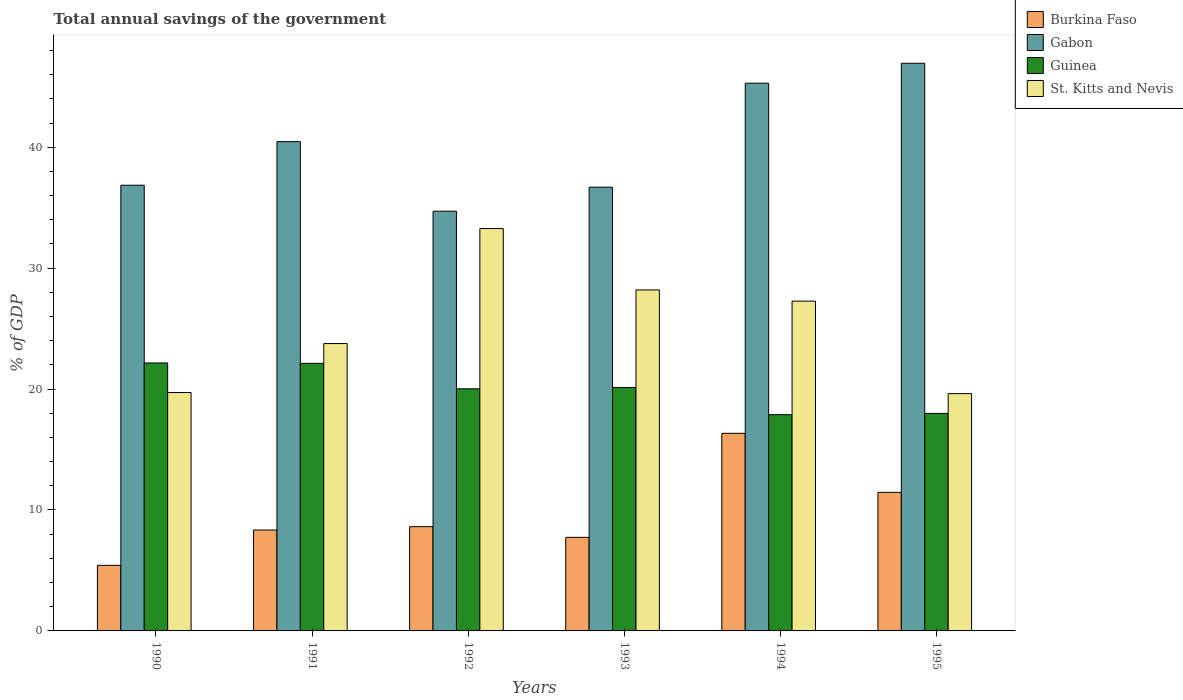Are the number of bars per tick equal to the number of legend labels?
Your answer should be very brief. Yes. Are the number of bars on each tick of the X-axis equal?
Provide a succinct answer. Yes. How many bars are there on the 3rd tick from the left?
Make the answer very short. 4. What is the label of the 1st group of bars from the left?
Make the answer very short. 1990. In how many cases, is the number of bars for a given year not equal to the number of legend labels?
Provide a short and direct response. 0. What is the total annual savings of the government in St. Kitts and Nevis in 1991?
Provide a short and direct response. 23.76. Across all years, what is the maximum total annual savings of the government in Burkina Faso?
Your answer should be very brief. 16.34. Across all years, what is the minimum total annual savings of the government in Guinea?
Give a very brief answer. 17.88. In which year was the total annual savings of the government in Gabon maximum?
Provide a succinct answer. 1995. In which year was the total annual savings of the government in Burkina Faso minimum?
Ensure brevity in your answer.  1990. What is the total total annual savings of the government in St. Kitts and Nevis in the graph?
Ensure brevity in your answer.  151.84. What is the difference between the total annual savings of the government in Burkina Faso in 1993 and that in 1995?
Ensure brevity in your answer.  -3.72. What is the difference between the total annual savings of the government in Guinea in 1994 and the total annual savings of the government in Burkina Faso in 1995?
Keep it short and to the point. 6.42. What is the average total annual savings of the government in Guinea per year?
Offer a very short reply. 20.05. In the year 1994, what is the difference between the total annual savings of the government in Burkina Faso and total annual savings of the government in Guinea?
Offer a very short reply. -1.54. What is the ratio of the total annual savings of the government in Burkina Faso in 1990 to that in 1992?
Give a very brief answer. 0.63. What is the difference between the highest and the second highest total annual savings of the government in Burkina Faso?
Give a very brief answer. 4.88. What is the difference between the highest and the lowest total annual savings of the government in Burkina Faso?
Offer a terse response. 10.92. Is the sum of the total annual savings of the government in Gabon in 1991 and 1995 greater than the maximum total annual savings of the government in St. Kitts and Nevis across all years?
Offer a very short reply. Yes. What does the 1st bar from the left in 1995 represents?
Ensure brevity in your answer.  Burkina Faso. What does the 1st bar from the right in 1992 represents?
Offer a terse response. St. Kitts and Nevis. Are all the bars in the graph horizontal?
Ensure brevity in your answer.  No. Are the values on the major ticks of Y-axis written in scientific E-notation?
Your response must be concise. No. Does the graph contain any zero values?
Give a very brief answer. No. Does the graph contain grids?
Ensure brevity in your answer.  No. Where does the legend appear in the graph?
Offer a very short reply. Top right. How are the legend labels stacked?
Give a very brief answer. Vertical. What is the title of the graph?
Your answer should be compact. Total annual savings of the government. Does "South Sudan" appear as one of the legend labels in the graph?
Offer a very short reply. No. What is the label or title of the X-axis?
Make the answer very short. Years. What is the label or title of the Y-axis?
Your answer should be compact. % of GDP. What is the % of GDP in Burkina Faso in 1990?
Your answer should be compact. 5.42. What is the % of GDP in Gabon in 1990?
Offer a very short reply. 36.86. What is the % of GDP in Guinea in 1990?
Your answer should be very brief. 22.16. What is the % of GDP of St. Kitts and Nevis in 1990?
Your response must be concise. 19.71. What is the % of GDP of Burkina Faso in 1991?
Your answer should be compact. 8.34. What is the % of GDP of Gabon in 1991?
Keep it short and to the point. 40.46. What is the % of GDP in Guinea in 1991?
Provide a succinct answer. 22.13. What is the % of GDP of St. Kitts and Nevis in 1991?
Offer a terse response. 23.76. What is the % of GDP of Burkina Faso in 1992?
Give a very brief answer. 8.62. What is the % of GDP in Gabon in 1992?
Offer a very short reply. 34.71. What is the % of GDP in Guinea in 1992?
Your answer should be compact. 20.02. What is the % of GDP in St. Kitts and Nevis in 1992?
Your response must be concise. 33.27. What is the % of GDP in Burkina Faso in 1993?
Offer a terse response. 7.74. What is the % of GDP of Gabon in 1993?
Give a very brief answer. 36.69. What is the % of GDP of Guinea in 1993?
Provide a short and direct response. 20.13. What is the % of GDP in St. Kitts and Nevis in 1993?
Make the answer very short. 28.2. What is the % of GDP of Burkina Faso in 1994?
Ensure brevity in your answer.  16.34. What is the % of GDP of Gabon in 1994?
Give a very brief answer. 45.29. What is the % of GDP of Guinea in 1994?
Your response must be concise. 17.88. What is the % of GDP in St. Kitts and Nevis in 1994?
Offer a very short reply. 27.27. What is the % of GDP of Burkina Faso in 1995?
Your answer should be very brief. 11.46. What is the % of GDP in Gabon in 1995?
Your response must be concise. 46.94. What is the % of GDP in Guinea in 1995?
Your response must be concise. 17.99. What is the % of GDP in St. Kitts and Nevis in 1995?
Ensure brevity in your answer.  19.62. Across all years, what is the maximum % of GDP of Burkina Faso?
Provide a short and direct response. 16.34. Across all years, what is the maximum % of GDP of Gabon?
Make the answer very short. 46.94. Across all years, what is the maximum % of GDP of Guinea?
Give a very brief answer. 22.16. Across all years, what is the maximum % of GDP in St. Kitts and Nevis?
Ensure brevity in your answer.  33.27. Across all years, what is the minimum % of GDP of Burkina Faso?
Ensure brevity in your answer.  5.42. Across all years, what is the minimum % of GDP in Gabon?
Make the answer very short. 34.71. Across all years, what is the minimum % of GDP in Guinea?
Give a very brief answer. 17.88. Across all years, what is the minimum % of GDP in St. Kitts and Nevis?
Your response must be concise. 19.62. What is the total % of GDP of Burkina Faso in the graph?
Your answer should be compact. 57.93. What is the total % of GDP of Gabon in the graph?
Ensure brevity in your answer.  240.95. What is the total % of GDP of Guinea in the graph?
Make the answer very short. 120.31. What is the total % of GDP of St. Kitts and Nevis in the graph?
Provide a succinct answer. 151.84. What is the difference between the % of GDP in Burkina Faso in 1990 and that in 1991?
Your answer should be very brief. -2.92. What is the difference between the % of GDP of Gabon in 1990 and that in 1991?
Your answer should be compact. -3.6. What is the difference between the % of GDP in Guinea in 1990 and that in 1991?
Your response must be concise. 0.03. What is the difference between the % of GDP in St. Kitts and Nevis in 1990 and that in 1991?
Provide a succinct answer. -4.05. What is the difference between the % of GDP of Burkina Faso in 1990 and that in 1992?
Your answer should be compact. -3.2. What is the difference between the % of GDP of Gabon in 1990 and that in 1992?
Offer a very short reply. 2.15. What is the difference between the % of GDP in Guinea in 1990 and that in 1992?
Offer a terse response. 2.14. What is the difference between the % of GDP of St. Kitts and Nevis in 1990 and that in 1992?
Offer a terse response. -13.56. What is the difference between the % of GDP of Burkina Faso in 1990 and that in 1993?
Your answer should be compact. -2.31. What is the difference between the % of GDP of Gabon in 1990 and that in 1993?
Provide a short and direct response. 0.16. What is the difference between the % of GDP in Guinea in 1990 and that in 1993?
Ensure brevity in your answer.  2.03. What is the difference between the % of GDP in St. Kitts and Nevis in 1990 and that in 1993?
Provide a succinct answer. -8.48. What is the difference between the % of GDP of Burkina Faso in 1990 and that in 1994?
Give a very brief answer. -10.92. What is the difference between the % of GDP in Gabon in 1990 and that in 1994?
Provide a succinct answer. -8.44. What is the difference between the % of GDP in Guinea in 1990 and that in 1994?
Make the answer very short. 4.28. What is the difference between the % of GDP of St. Kitts and Nevis in 1990 and that in 1994?
Keep it short and to the point. -7.56. What is the difference between the % of GDP in Burkina Faso in 1990 and that in 1995?
Your response must be concise. -6.03. What is the difference between the % of GDP of Gabon in 1990 and that in 1995?
Offer a very short reply. -10.09. What is the difference between the % of GDP of Guinea in 1990 and that in 1995?
Your answer should be compact. 4.17. What is the difference between the % of GDP in St. Kitts and Nevis in 1990 and that in 1995?
Provide a succinct answer. 0.09. What is the difference between the % of GDP of Burkina Faso in 1991 and that in 1992?
Offer a very short reply. -0.28. What is the difference between the % of GDP in Gabon in 1991 and that in 1992?
Your answer should be compact. 5.75. What is the difference between the % of GDP of Guinea in 1991 and that in 1992?
Your answer should be compact. 2.11. What is the difference between the % of GDP in St. Kitts and Nevis in 1991 and that in 1992?
Make the answer very short. -9.51. What is the difference between the % of GDP of Burkina Faso in 1991 and that in 1993?
Provide a succinct answer. 0.61. What is the difference between the % of GDP of Gabon in 1991 and that in 1993?
Your answer should be very brief. 3.77. What is the difference between the % of GDP of Guinea in 1991 and that in 1993?
Ensure brevity in your answer.  2. What is the difference between the % of GDP in St. Kitts and Nevis in 1991 and that in 1993?
Offer a terse response. -4.43. What is the difference between the % of GDP in Burkina Faso in 1991 and that in 1994?
Your response must be concise. -8. What is the difference between the % of GDP in Gabon in 1991 and that in 1994?
Give a very brief answer. -4.83. What is the difference between the % of GDP in Guinea in 1991 and that in 1994?
Your answer should be compact. 4.25. What is the difference between the % of GDP in St. Kitts and Nevis in 1991 and that in 1994?
Your answer should be very brief. -3.51. What is the difference between the % of GDP of Burkina Faso in 1991 and that in 1995?
Provide a short and direct response. -3.11. What is the difference between the % of GDP of Gabon in 1991 and that in 1995?
Offer a terse response. -6.48. What is the difference between the % of GDP in Guinea in 1991 and that in 1995?
Your answer should be very brief. 4.14. What is the difference between the % of GDP of St. Kitts and Nevis in 1991 and that in 1995?
Provide a short and direct response. 4.14. What is the difference between the % of GDP in Burkina Faso in 1992 and that in 1993?
Offer a very short reply. 0.88. What is the difference between the % of GDP in Gabon in 1992 and that in 1993?
Keep it short and to the point. -1.99. What is the difference between the % of GDP of Guinea in 1992 and that in 1993?
Your answer should be compact. -0.11. What is the difference between the % of GDP in St. Kitts and Nevis in 1992 and that in 1993?
Your response must be concise. 5.08. What is the difference between the % of GDP of Burkina Faso in 1992 and that in 1994?
Give a very brief answer. -7.72. What is the difference between the % of GDP of Gabon in 1992 and that in 1994?
Your answer should be very brief. -10.58. What is the difference between the % of GDP of Guinea in 1992 and that in 1994?
Your response must be concise. 2.14. What is the difference between the % of GDP in St. Kitts and Nevis in 1992 and that in 1994?
Provide a succinct answer. 6. What is the difference between the % of GDP of Burkina Faso in 1992 and that in 1995?
Keep it short and to the point. -2.84. What is the difference between the % of GDP of Gabon in 1992 and that in 1995?
Provide a succinct answer. -12.24. What is the difference between the % of GDP of Guinea in 1992 and that in 1995?
Give a very brief answer. 2.03. What is the difference between the % of GDP in St. Kitts and Nevis in 1992 and that in 1995?
Your response must be concise. 13.65. What is the difference between the % of GDP in Burkina Faso in 1993 and that in 1994?
Your response must be concise. -8.6. What is the difference between the % of GDP of Gabon in 1993 and that in 1994?
Give a very brief answer. -8.6. What is the difference between the % of GDP in Guinea in 1993 and that in 1994?
Offer a terse response. 2.25. What is the difference between the % of GDP in St. Kitts and Nevis in 1993 and that in 1994?
Ensure brevity in your answer.  0.93. What is the difference between the % of GDP in Burkina Faso in 1993 and that in 1995?
Keep it short and to the point. -3.72. What is the difference between the % of GDP in Gabon in 1993 and that in 1995?
Make the answer very short. -10.25. What is the difference between the % of GDP in Guinea in 1993 and that in 1995?
Offer a terse response. 2.14. What is the difference between the % of GDP in St. Kitts and Nevis in 1993 and that in 1995?
Provide a succinct answer. 8.57. What is the difference between the % of GDP in Burkina Faso in 1994 and that in 1995?
Ensure brevity in your answer.  4.88. What is the difference between the % of GDP of Gabon in 1994 and that in 1995?
Give a very brief answer. -1.65. What is the difference between the % of GDP of Guinea in 1994 and that in 1995?
Give a very brief answer. -0.1. What is the difference between the % of GDP in St. Kitts and Nevis in 1994 and that in 1995?
Make the answer very short. 7.65. What is the difference between the % of GDP of Burkina Faso in 1990 and the % of GDP of Gabon in 1991?
Make the answer very short. -35.04. What is the difference between the % of GDP in Burkina Faso in 1990 and the % of GDP in Guinea in 1991?
Your answer should be very brief. -16.71. What is the difference between the % of GDP in Burkina Faso in 1990 and the % of GDP in St. Kitts and Nevis in 1991?
Offer a very short reply. -18.34. What is the difference between the % of GDP in Gabon in 1990 and the % of GDP in Guinea in 1991?
Ensure brevity in your answer.  14.73. What is the difference between the % of GDP of Gabon in 1990 and the % of GDP of St. Kitts and Nevis in 1991?
Make the answer very short. 13.09. What is the difference between the % of GDP of Guinea in 1990 and the % of GDP of St. Kitts and Nevis in 1991?
Ensure brevity in your answer.  -1.6. What is the difference between the % of GDP of Burkina Faso in 1990 and the % of GDP of Gabon in 1992?
Provide a short and direct response. -29.28. What is the difference between the % of GDP of Burkina Faso in 1990 and the % of GDP of Guinea in 1992?
Provide a short and direct response. -14.6. What is the difference between the % of GDP of Burkina Faso in 1990 and the % of GDP of St. Kitts and Nevis in 1992?
Provide a succinct answer. -27.85. What is the difference between the % of GDP of Gabon in 1990 and the % of GDP of Guinea in 1992?
Provide a succinct answer. 16.84. What is the difference between the % of GDP in Gabon in 1990 and the % of GDP in St. Kitts and Nevis in 1992?
Your answer should be very brief. 3.58. What is the difference between the % of GDP in Guinea in 1990 and the % of GDP in St. Kitts and Nevis in 1992?
Offer a terse response. -11.11. What is the difference between the % of GDP of Burkina Faso in 1990 and the % of GDP of Gabon in 1993?
Provide a succinct answer. -31.27. What is the difference between the % of GDP in Burkina Faso in 1990 and the % of GDP in Guinea in 1993?
Offer a terse response. -14.71. What is the difference between the % of GDP in Burkina Faso in 1990 and the % of GDP in St. Kitts and Nevis in 1993?
Keep it short and to the point. -22.77. What is the difference between the % of GDP in Gabon in 1990 and the % of GDP in Guinea in 1993?
Offer a very short reply. 16.73. What is the difference between the % of GDP of Gabon in 1990 and the % of GDP of St. Kitts and Nevis in 1993?
Provide a succinct answer. 8.66. What is the difference between the % of GDP in Guinea in 1990 and the % of GDP in St. Kitts and Nevis in 1993?
Your answer should be very brief. -6.04. What is the difference between the % of GDP of Burkina Faso in 1990 and the % of GDP of Gabon in 1994?
Your answer should be very brief. -39.87. What is the difference between the % of GDP in Burkina Faso in 1990 and the % of GDP in Guinea in 1994?
Keep it short and to the point. -12.46. What is the difference between the % of GDP of Burkina Faso in 1990 and the % of GDP of St. Kitts and Nevis in 1994?
Offer a very short reply. -21.85. What is the difference between the % of GDP in Gabon in 1990 and the % of GDP in Guinea in 1994?
Ensure brevity in your answer.  18.97. What is the difference between the % of GDP of Gabon in 1990 and the % of GDP of St. Kitts and Nevis in 1994?
Give a very brief answer. 9.58. What is the difference between the % of GDP of Guinea in 1990 and the % of GDP of St. Kitts and Nevis in 1994?
Keep it short and to the point. -5.11. What is the difference between the % of GDP of Burkina Faso in 1990 and the % of GDP of Gabon in 1995?
Make the answer very short. -41.52. What is the difference between the % of GDP in Burkina Faso in 1990 and the % of GDP in Guinea in 1995?
Offer a terse response. -12.56. What is the difference between the % of GDP of Burkina Faso in 1990 and the % of GDP of St. Kitts and Nevis in 1995?
Offer a very short reply. -14.2. What is the difference between the % of GDP of Gabon in 1990 and the % of GDP of Guinea in 1995?
Ensure brevity in your answer.  18.87. What is the difference between the % of GDP in Gabon in 1990 and the % of GDP in St. Kitts and Nevis in 1995?
Ensure brevity in your answer.  17.23. What is the difference between the % of GDP in Guinea in 1990 and the % of GDP in St. Kitts and Nevis in 1995?
Offer a very short reply. 2.54. What is the difference between the % of GDP in Burkina Faso in 1991 and the % of GDP in Gabon in 1992?
Your response must be concise. -26.36. What is the difference between the % of GDP of Burkina Faso in 1991 and the % of GDP of Guinea in 1992?
Keep it short and to the point. -11.68. What is the difference between the % of GDP in Burkina Faso in 1991 and the % of GDP in St. Kitts and Nevis in 1992?
Offer a terse response. -24.93. What is the difference between the % of GDP of Gabon in 1991 and the % of GDP of Guinea in 1992?
Offer a very short reply. 20.44. What is the difference between the % of GDP of Gabon in 1991 and the % of GDP of St. Kitts and Nevis in 1992?
Provide a short and direct response. 7.19. What is the difference between the % of GDP of Guinea in 1991 and the % of GDP of St. Kitts and Nevis in 1992?
Offer a terse response. -11.14. What is the difference between the % of GDP in Burkina Faso in 1991 and the % of GDP in Gabon in 1993?
Give a very brief answer. -28.35. What is the difference between the % of GDP of Burkina Faso in 1991 and the % of GDP of Guinea in 1993?
Your answer should be very brief. -11.79. What is the difference between the % of GDP in Burkina Faso in 1991 and the % of GDP in St. Kitts and Nevis in 1993?
Ensure brevity in your answer.  -19.85. What is the difference between the % of GDP of Gabon in 1991 and the % of GDP of Guinea in 1993?
Provide a short and direct response. 20.33. What is the difference between the % of GDP in Gabon in 1991 and the % of GDP in St. Kitts and Nevis in 1993?
Keep it short and to the point. 12.26. What is the difference between the % of GDP in Guinea in 1991 and the % of GDP in St. Kitts and Nevis in 1993?
Provide a short and direct response. -6.07. What is the difference between the % of GDP of Burkina Faso in 1991 and the % of GDP of Gabon in 1994?
Your answer should be very brief. -36.95. What is the difference between the % of GDP in Burkina Faso in 1991 and the % of GDP in Guinea in 1994?
Ensure brevity in your answer.  -9.54. What is the difference between the % of GDP in Burkina Faso in 1991 and the % of GDP in St. Kitts and Nevis in 1994?
Your answer should be compact. -18.93. What is the difference between the % of GDP in Gabon in 1991 and the % of GDP in Guinea in 1994?
Your answer should be very brief. 22.58. What is the difference between the % of GDP of Gabon in 1991 and the % of GDP of St. Kitts and Nevis in 1994?
Keep it short and to the point. 13.19. What is the difference between the % of GDP of Guinea in 1991 and the % of GDP of St. Kitts and Nevis in 1994?
Your answer should be compact. -5.14. What is the difference between the % of GDP in Burkina Faso in 1991 and the % of GDP in Gabon in 1995?
Provide a succinct answer. -38.6. What is the difference between the % of GDP in Burkina Faso in 1991 and the % of GDP in Guinea in 1995?
Give a very brief answer. -9.64. What is the difference between the % of GDP of Burkina Faso in 1991 and the % of GDP of St. Kitts and Nevis in 1995?
Offer a very short reply. -11.28. What is the difference between the % of GDP of Gabon in 1991 and the % of GDP of Guinea in 1995?
Make the answer very short. 22.47. What is the difference between the % of GDP of Gabon in 1991 and the % of GDP of St. Kitts and Nevis in 1995?
Provide a succinct answer. 20.84. What is the difference between the % of GDP in Guinea in 1991 and the % of GDP in St. Kitts and Nevis in 1995?
Ensure brevity in your answer.  2.51. What is the difference between the % of GDP in Burkina Faso in 1992 and the % of GDP in Gabon in 1993?
Your answer should be compact. -28.07. What is the difference between the % of GDP of Burkina Faso in 1992 and the % of GDP of Guinea in 1993?
Give a very brief answer. -11.51. What is the difference between the % of GDP in Burkina Faso in 1992 and the % of GDP in St. Kitts and Nevis in 1993?
Your answer should be compact. -19.58. What is the difference between the % of GDP in Gabon in 1992 and the % of GDP in Guinea in 1993?
Keep it short and to the point. 14.58. What is the difference between the % of GDP in Gabon in 1992 and the % of GDP in St. Kitts and Nevis in 1993?
Ensure brevity in your answer.  6.51. What is the difference between the % of GDP in Guinea in 1992 and the % of GDP in St. Kitts and Nevis in 1993?
Your answer should be compact. -8.18. What is the difference between the % of GDP in Burkina Faso in 1992 and the % of GDP in Gabon in 1994?
Provide a succinct answer. -36.67. What is the difference between the % of GDP of Burkina Faso in 1992 and the % of GDP of Guinea in 1994?
Provide a short and direct response. -9.26. What is the difference between the % of GDP of Burkina Faso in 1992 and the % of GDP of St. Kitts and Nevis in 1994?
Give a very brief answer. -18.65. What is the difference between the % of GDP in Gabon in 1992 and the % of GDP in Guinea in 1994?
Make the answer very short. 16.82. What is the difference between the % of GDP in Gabon in 1992 and the % of GDP in St. Kitts and Nevis in 1994?
Offer a very short reply. 7.43. What is the difference between the % of GDP in Guinea in 1992 and the % of GDP in St. Kitts and Nevis in 1994?
Provide a short and direct response. -7.25. What is the difference between the % of GDP of Burkina Faso in 1992 and the % of GDP of Gabon in 1995?
Ensure brevity in your answer.  -38.32. What is the difference between the % of GDP in Burkina Faso in 1992 and the % of GDP in Guinea in 1995?
Your response must be concise. -9.37. What is the difference between the % of GDP of Burkina Faso in 1992 and the % of GDP of St. Kitts and Nevis in 1995?
Provide a succinct answer. -11. What is the difference between the % of GDP in Gabon in 1992 and the % of GDP in Guinea in 1995?
Keep it short and to the point. 16.72. What is the difference between the % of GDP in Gabon in 1992 and the % of GDP in St. Kitts and Nevis in 1995?
Keep it short and to the point. 15.08. What is the difference between the % of GDP of Guinea in 1992 and the % of GDP of St. Kitts and Nevis in 1995?
Ensure brevity in your answer.  0.4. What is the difference between the % of GDP in Burkina Faso in 1993 and the % of GDP in Gabon in 1994?
Give a very brief answer. -37.55. What is the difference between the % of GDP in Burkina Faso in 1993 and the % of GDP in Guinea in 1994?
Offer a very short reply. -10.15. What is the difference between the % of GDP in Burkina Faso in 1993 and the % of GDP in St. Kitts and Nevis in 1994?
Keep it short and to the point. -19.54. What is the difference between the % of GDP in Gabon in 1993 and the % of GDP in Guinea in 1994?
Make the answer very short. 18.81. What is the difference between the % of GDP of Gabon in 1993 and the % of GDP of St. Kitts and Nevis in 1994?
Give a very brief answer. 9.42. What is the difference between the % of GDP in Guinea in 1993 and the % of GDP in St. Kitts and Nevis in 1994?
Your answer should be compact. -7.14. What is the difference between the % of GDP in Burkina Faso in 1993 and the % of GDP in Gabon in 1995?
Your response must be concise. -39.21. What is the difference between the % of GDP of Burkina Faso in 1993 and the % of GDP of Guinea in 1995?
Make the answer very short. -10.25. What is the difference between the % of GDP of Burkina Faso in 1993 and the % of GDP of St. Kitts and Nevis in 1995?
Keep it short and to the point. -11.89. What is the difference between the % of GDP in Gabon in 1993 and the % of GDP in Guinea in 1995?
Offer a terse response. 18.71. What is the difference between the % of GDP in Gabon in 1993 and the % of GDP in St. Kitts and Nevis in 1995?
Your answer should be compact. 17.07. What is the difference between the % of GDP in Guinea in 1993 and the % of GDP in St. Kitts and Nevis in 1995?
Keep it short and to the point. 0.51. What is the difference between the % of GDP in Burkina Faso in 1994 and the % of GDP in Gabon in 1995?
Your answer should be very brief. -30.6. What is the difference between the % of GDP in Burkina Faso in 1994 and the % of GDP in Guinea in 1995?
Your answer should be very brief. -1.65. What is the difference between the % of GDP of Burkina Faso in 1994 and the % of GDP of St. Kitts and Nevis in 1995?
Provide a succinct answer. -3.28. What is the difference between the % of GDP in Gabon in 1994 and the % of GDP in Guinea in 1995?
Give a very brief answer. 27.31. What is the difference between the % of GDP of Gabon in 1994 and the % of GDP of St. Kitts and Nevis in 1995?
Offer a terse response. 25.67. What is the difference between the % of GDP in Guinea in 1994 and the % of GDP in St. Kitts and Nevis in 1995?
Your answer should be very brief. -1.74. What is the average % of GDP of Burkina Faso per year?
Your answer should be very brief. 9.65. What is the average % of GDP in Gabon per year?
Keep it short and to the point. 40.16. What is the average % of GDP of Guinea per year?
Your answer should be compact. 20.05. What is the average % of GDP in St. Kitts and Nevis per year?
Give a very brief answer. 25.31. In the year 1990, what is the difference between the % of GDP of Burkina Faso and % of GDP of Gabon?
Your answer should be very brief. -31.43. In the year 1990, what is the difference between the % of GDP in Burkina Faso and % of GDP in Guinea?
Your response must be concise. -16.74. In the year 1990, what is the difference between the % of GDP in Burkina Faso and % of GDP in St. Kitts and Nevis?
Your response must be concise. -14.29. In the year 1990, what is the difference between the % of GDP of Gabon and % of GDP of Guinea?
Keep it short and to the point. 14.7. In the year 1990, what is the difference between the % of GDP of Gabon and % of GDP of St. Kitts and Nevis?
Ensure brevity in your answer.  17.14. In the year 1990, what is the difference between the % of GDP in Guinea and % of GDP in St. Kitts and Nevis?
Provide a short and direct response. 2.44. In the year 1991, what is the difference between the % of GDP in Burkina Faso and % of GDP in Gabon?
Your answer should be compact. -32.12. In the year 1991, what is the difference between the % of GDP of Burkina Faso and % of GDP of Guinea?
Your answer should be compact. -13.79. In the year 1991, what is the difference between the % of GDP of Burkina Faso and % of GDP of St. Kitts and Nevis?
Give a very brief answer. -15.42. In the year 1991, what is the difference between the % of GDP in Gabon and % of GDP in Guinea?
Provide a succinct answer. 18.33. In the year 1991, what is the difference between the % of GDP in Gabon and % of GDP in St. Kitts and Nevis?
Your answer should be very brief. 16.7. In the year 1991, what is the difference between the % of GDP of Guinea and % of GDP of St. Kitts and Nevis?
Your response must be concise. -1.63. In the year 1992, what is the difference between the % of GDP in Burkina Faso and % of GDP in Gabon?
Ensure brevity in your answer.  -26.09. In the year 1992, what is the difference between the % of GDP in Burkina Faso and % of GDP in Guinea?
Keep it short and to the point. -11.4. In the year 1992, what is the difference between the % of GDP in Burkina Faso and % of GDP in St. Kitts and Nevis?
Your answer should be compact. -24.65. In the year 1992, what is the difference between the % of GDP in Gabon and % of GDP in Guinea?
Your answer should be very brief. 14.69. In the year 1992, what is the difference between the % of GDP of Gabon and % of GDP of St. Kitts and Nevis?
Ensure brevity in your answer.  1.43. In the year 1992, what is the difference between the % of GDP of Guinea and % of GDP of St. Kitts and Nevis?
Your response must be concise. -13.25. In the year 1993, what is the difference between the % of GDP of Burkina Faso and % of GDP of Gabon?
Offer a terse response. -28.96. In the year 1993, what is the difference between the % of GDP in Burkina Faso and % of GDP in Guinea?
Keep it short and to the point. -12.39. In the year 1993, what is the difference between the % of GDP of Burkina Faso and % of GDP of St. Kitts and Nevis?
Offer a very short reply. -20.46. In the year 1993, what is the difference between the % of GDP in Gabon and % of GDP in Guinea?
Your answer should be compact. 16.56. In the year 1993, what is the difference between the % of GDP in Gabon and % of GDP in St. Kitts and Nevis?
Offer a very short reply. 8.5. In the year 1993, what is the difference between the % of GDP in Guinea and % of GDP in St. Kitts and Nevis?
Your response must be concise. -8.07. In the year 1994, what is the difference between the % of GDP in Burkina Faso and % of GDP in Gabon?
Make the answer very short. -28.95. In the year 1994, what is the difference between the % of GDP of Burkina Faso and % of GDP of Guinea?
Provide a short and direct response. -1.54. In the year 1994, what is the difference between the % of GDP of Burkina Faso and % of GDP of St. Kitts and Nevis?
Provide a succinct answer. -10.93. In the year 1994, what is the difference between the % of GDP in Gabon and % of GDP in Guinea?
Give a very brief answer. 27.41. In the year 1994, what is the difference between the % of GDP of Gabon and % of GDP of St. Kitts and Nevis?
Provide a succinct answer. 18.02. In the year 1994, what is the difference between the % of GDP in Guinea and % of GDP in St. Kitts and Nevis?
Offer a terse response. -9.39. In the year 1995, what is the difference between the % of GDP in Burkina Faso and % of GDP in Gabon?
Ensure brevity in your answer.  -35.48. In the year 1995, what is the difference between the % of GDP of Burkina Faso and % of GDP of Guinea?
Your answer should be compact. -6.53. In the year 1995, what is the difference between the % of GDP in Burkina Faso and % of GDP in St. Kitts and Nevis?
Give a very brief answer. -8.16. In the year 1995, what is the difference between the % of GDP in Gabon and % of GDP in Guinea?
Provide a short and direct response. 28.96. In the year 1995, what is the difference between the % of GDP in Gabon and % of GDP in St. Kitts and Nevis?
Ensure brevity in your answer.  27.32. In the year 1995, what is the difference between the % of GDP of Guinea and % of GDP of St. Kitts and Nevis?
Ensure brevity in your answer.  -1.64. What is the ratio of the % of GDP of Burkina Faso in 1990 to that in 1991?
Your response must be concise. 0.65. What is the ratio of the % of GDP in Gabon in 1990 to that in 1991?
Offer a terse response. 0.91. What is the ratio of the % of GDP in St. Kitts and Nevis in 1990 to that in 1991?
Your answer should be very brief. 0.83. What is the ratio of the % of GDP of Burkina Faso in 1990 to that in 1992?
Give a very brief answer. 0.63. What is the ratio of the % of GDP in Gabon in 1990 to that in 1992?
Your answer should be compact. 1.06. What is the ratio of the % of GDP in Guinea in 1990 to that in 1992?
Your answer should be compact. 1.11. What is the ratio of the % of GDP in St. Kitts and Nevis in 1990 to that in 1992?
Ensure brevity in your answer.  0.59. What is the ratio of the % of GDP in Burkina Faso in 1990 to that in 1993?
Offer a terse response. 0.7. What is the ratio of the % of GDP in Gabon in 1990 to that in 1993?
Offer a terse response. 1. What is the ratio of the % of GDP in Guinea in 1990 to that in 1993?
Make the answer very short. 1.1. What is the ratio of the % of GDP of St. Kitts and Nevis in 1990 to that in 1993?
Offer a very short reply. 0.7. What is the ratio of the % of GDP in Burkina Faso in 1990 to that in 1994?
Provide a short and direct response. 0.33. What is the ratio of the % of GDP in Gabon in 1990 to that in 1994?
Your answer should be compact. 0.81. What is the ratio of the % of GDP in Guinea in 1990 to that in 1994?
Offer a terse response. 1.24. What is the ratio of the % of GDP of St. Kitts and Nevis in 1990 to that in 1994?
Your response must be concise. 0.72. What is the ratio of the % of GDP of Burkina Faso in 1990 to that in 1995?
Keep it short and to the point. 0.47. What is the ratio of the % of GDP in Gabon in 1990 to that in 1995?
Keep it short and to the point. 0.79. What is the ratio of the % of GDP in Guinea in 1990 to that in 1995?
Your answer should be very brief. 1.23. What is the ratio of the % of GDP of Burkina Faso in 1991 to that in 1992?
Give a very brief answer. 0.97. What is the ratio of the % of GDP in Gabon in 1991 to that in 1992?
Provide a succinct answer. 1.17. What is the ratio of the % of GDP in Guinea in 1991 to that in 1992?
Your answer should be very brief. 1.11. What is the ratio of the % of GDP in St. Kitts and Nevis in 1991 to that in 1992?
Your response must be concise. 0.71. What is the ratio of the % of GDP of Burkina Faso in 1991 to that in 1993?
Offer a terse response. 1.08. What is the ratio of the % of GDP of Gabon in 1991 to that in 1993?
Offer a very short reply. 1.1. What is the ratio of the % of GDP in Guinea in 1991 to that in 1993?
Provide a succinct answer. 1.1. What is the ratio of the % of GDP in St. Kitts and Nevis in 1991 to that in 1993?
Your answer should be very brief. 0.84. What is the ratio of the % of GDP in Burkina Faso in 1991 to that in 1994?
Make the answer very short. 0.51. What is the ratio of the % of GDP of Gabon in 1991 to that in 1994?
Give a very brief answer. 0.89. What is the ratio of the % of GDP of Guinea in 1991 to that in 1994?
Offer a terse response. 1.24. What is the ratio of the % of GDP in St. Kitts and Nevis in 1991 to that in 1994?
Make the answer very short. 0.87. What is the ratio of the % of GDP of Burkina Faso in 1991 to that in 1995?
Your response must be concise. 0.73. What is the ratio of the % of GDP in Gabon in 1991 to that in 1995?
Provide a short and direct response. 0.86. What is the ratio of the % of GDP in Guinea in 1991 to that in 1995?
Give a very brief answer. 1.23. What is the ratio of the % of GDP of St. Kitts and Nevis in 1991 to that in 1995?
Offer a terse response. 1.21. What is the ratio of the % of GDP of Burkina Faso in 1992 to that in 1993?
Make the answer very short. 1.11. What is the ratio of the % of GDP in Gabon in 1992 to that in 1993?
Make the answer very short. 0.95. What is the ratio of the % of GDP in St. Kitts and Nevis in 1992 to that in 1993?
Provide a short and direct response. 1.18. What is the ratio of the % of GDP in Burkina Faso in 1992 to that in 1994?
Offer a very short reply. 0.53. What is the ratio of the % of GDP in Gabon in 1992 to that in 1994?
Make the answer very short. 0.77. What is the ratio of the % of GDP of Guinea in 1992 to that in 1994?
Offer a very short reply. 1.12. What is the ratio of the % of GDP of St. Kitts and Nevis in 1992 to that in 1994?
Offer a very short reply. 1.22. What is the ratio of the % of GDP of Burkina Faso in 1992 to that in 1995?
Your response must be concise. 0.75. What is the ratio of the % of GDP of Gabon in 1992 to that in 1995?
Your response must be concise. 0.74. What is the ratio of the % of GDP of Guinea in 1992 to that in 1995?
Offer a terse response. 1.11. What is the ratio of the % of GDP in St. Kitts and Nevis in 1992 to that in 1995?
Your answer should be compact. 1.7. What is the ratio of the % of GDP of Burkina Faso in 1993 to that in 1994?
Your answer should be very brief. 0.47. What is the ratio of the % of GDP in Gabon in 1993 to that in 1994?
Your answer should be compact. 0.81. What is the ratio of the % of GDP of Guinea in 1993 to that in 1994?
Ensure brevity in your answer.  1.13. What is the ratio of the % of GDP of St. Kitts and Nevis in 1993 to that in 1994?
Your answer should be very brief. 1.03. What is the ratio of the % of GDP in Burkina Faso in 1993 to that in 1995?
Provide a succinct answer. 0.68. What is the ratio of the % of GDP in Gabon in 1993 to that in 1995?
Offer a very short reply. 0.78. What is the ratio of the % of GDP of Guinea in 1993 to that in 1995?
Your answer should be compact. 1.12. What is the ratio of the % of GDP in St. Kitts and Nevis in 1993 to that in 1995?
Offer a terse response. 1.44. What is the ratio of the % of GDP in Burkina Faso in 1994 to that in 1995?
Your answer should be compact. 1.43. What is the ratio of the % of GDP in Gabon in 1994 to that in 1995?
Provide a short and direct response. 0.96. What is the ratio of the % of GDP in Guinea in 1994 to that in 1995?
Provide a short and direct response. 0.99. What is the ratio of the % of GDP of St. Kitts and Nevis in 1994 to that in 1995?
Offer a very short reply. 1.39. What is the difference between the highest and the second highest % of GDP of Burkina Faso?
Offer a terse response. 4.88. What is the difference between the highest and the second highest % of GDP of Gabon?
Ensure brevity in your answer.  1.65. What is the difference between the highest and the second highest % of GDP in Guinea?
Your response must be concise. 0.03. What is the difference between the highest and the second highest % of GDP in St. Kitts and Nevis?
Offer a terse response. 5.08. What is the difference between the highest and the lowest % of GDP in Burkina Faso?
Offer a terse response. 10.92. What is the difference between the highest and the lowest % of GDP in Gabon?
Offer a terse response. 12.24. What is the difference between the highest and the lowest % of GDP of Guinea?
Offer a very short reply. 4.28. What is the difference between the highest and the lowest % of GDP in St. Kitts and Nevis?
Ensure brevity in your answer.  13.65. 